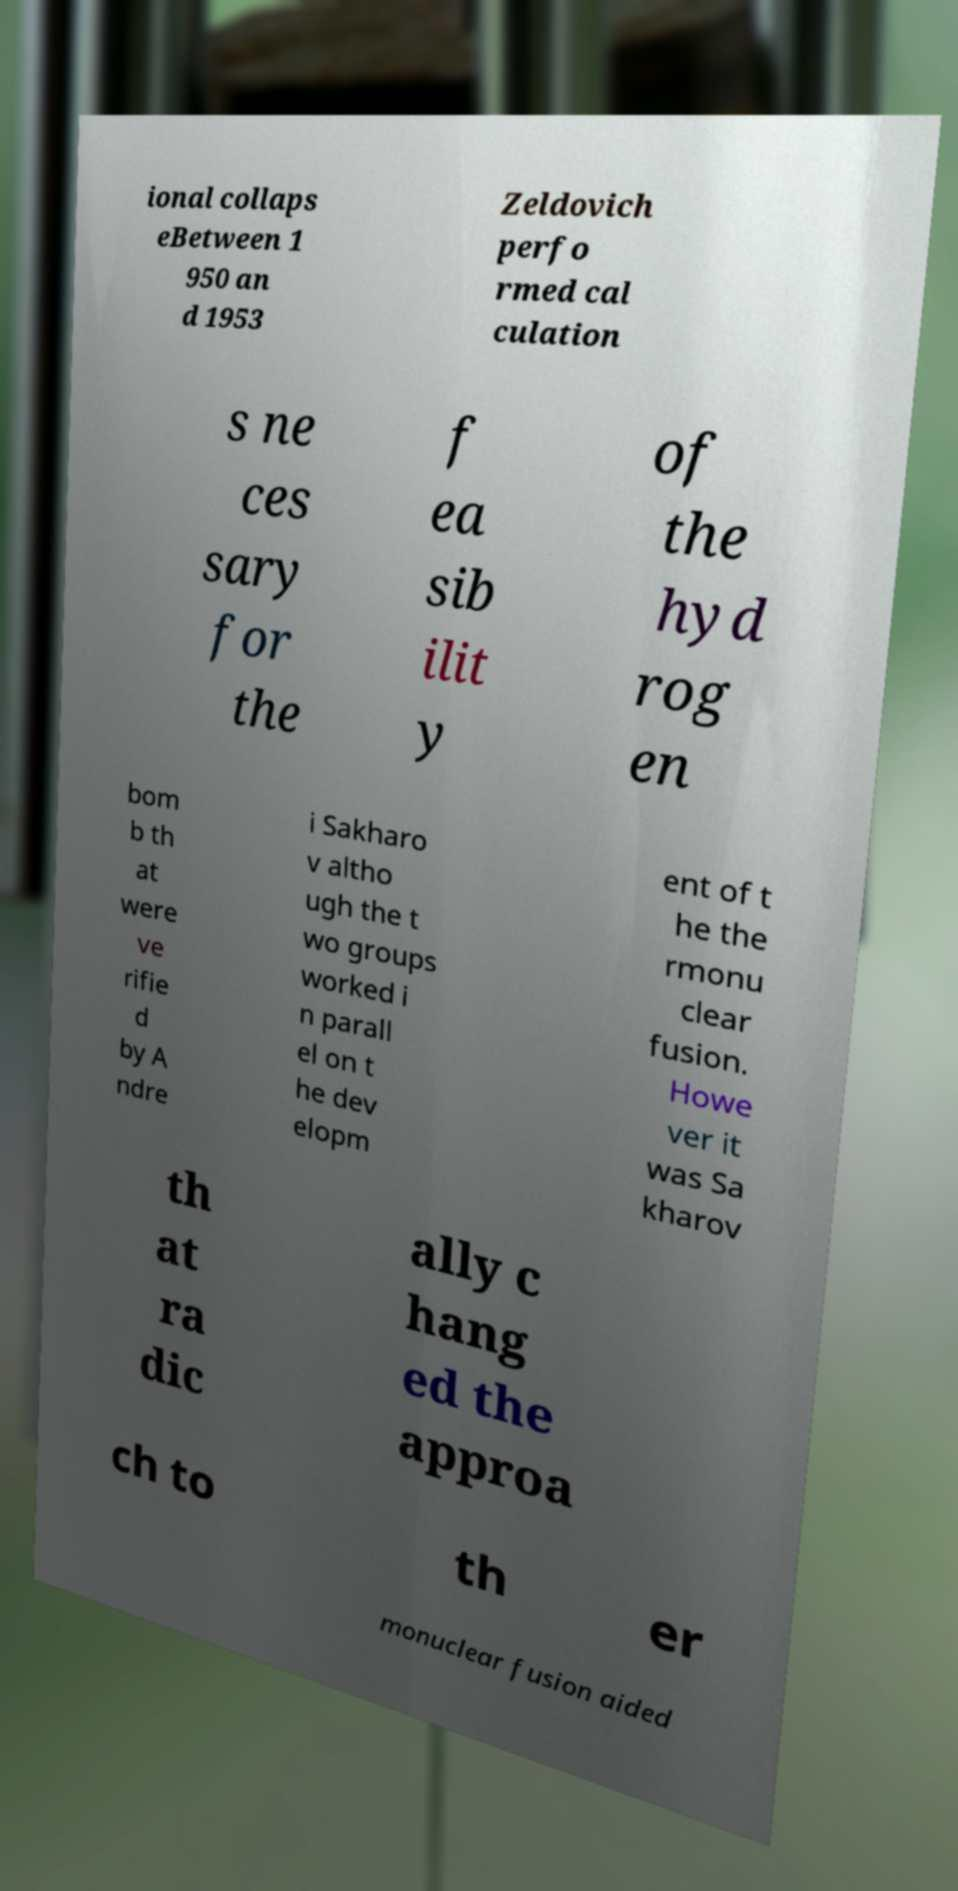Please read and relay the text visible in this image. What does it say? ional collaps eBetween 1 950 an d 1953 Zeldovich perfo rmed cal culation s ne ces sary for the f ea sib ilit y of the hyd rog en bom b th at were ve rifie d by A ndre i Sakharo v altho ugh the t wo groups worked i n parall el on t he dev elopm ent of t he the rmonu clear fusion. Howe ver it was Sa kharov th at ra dic ally c hang ed the approa ch to th er monuclear fusion aided 